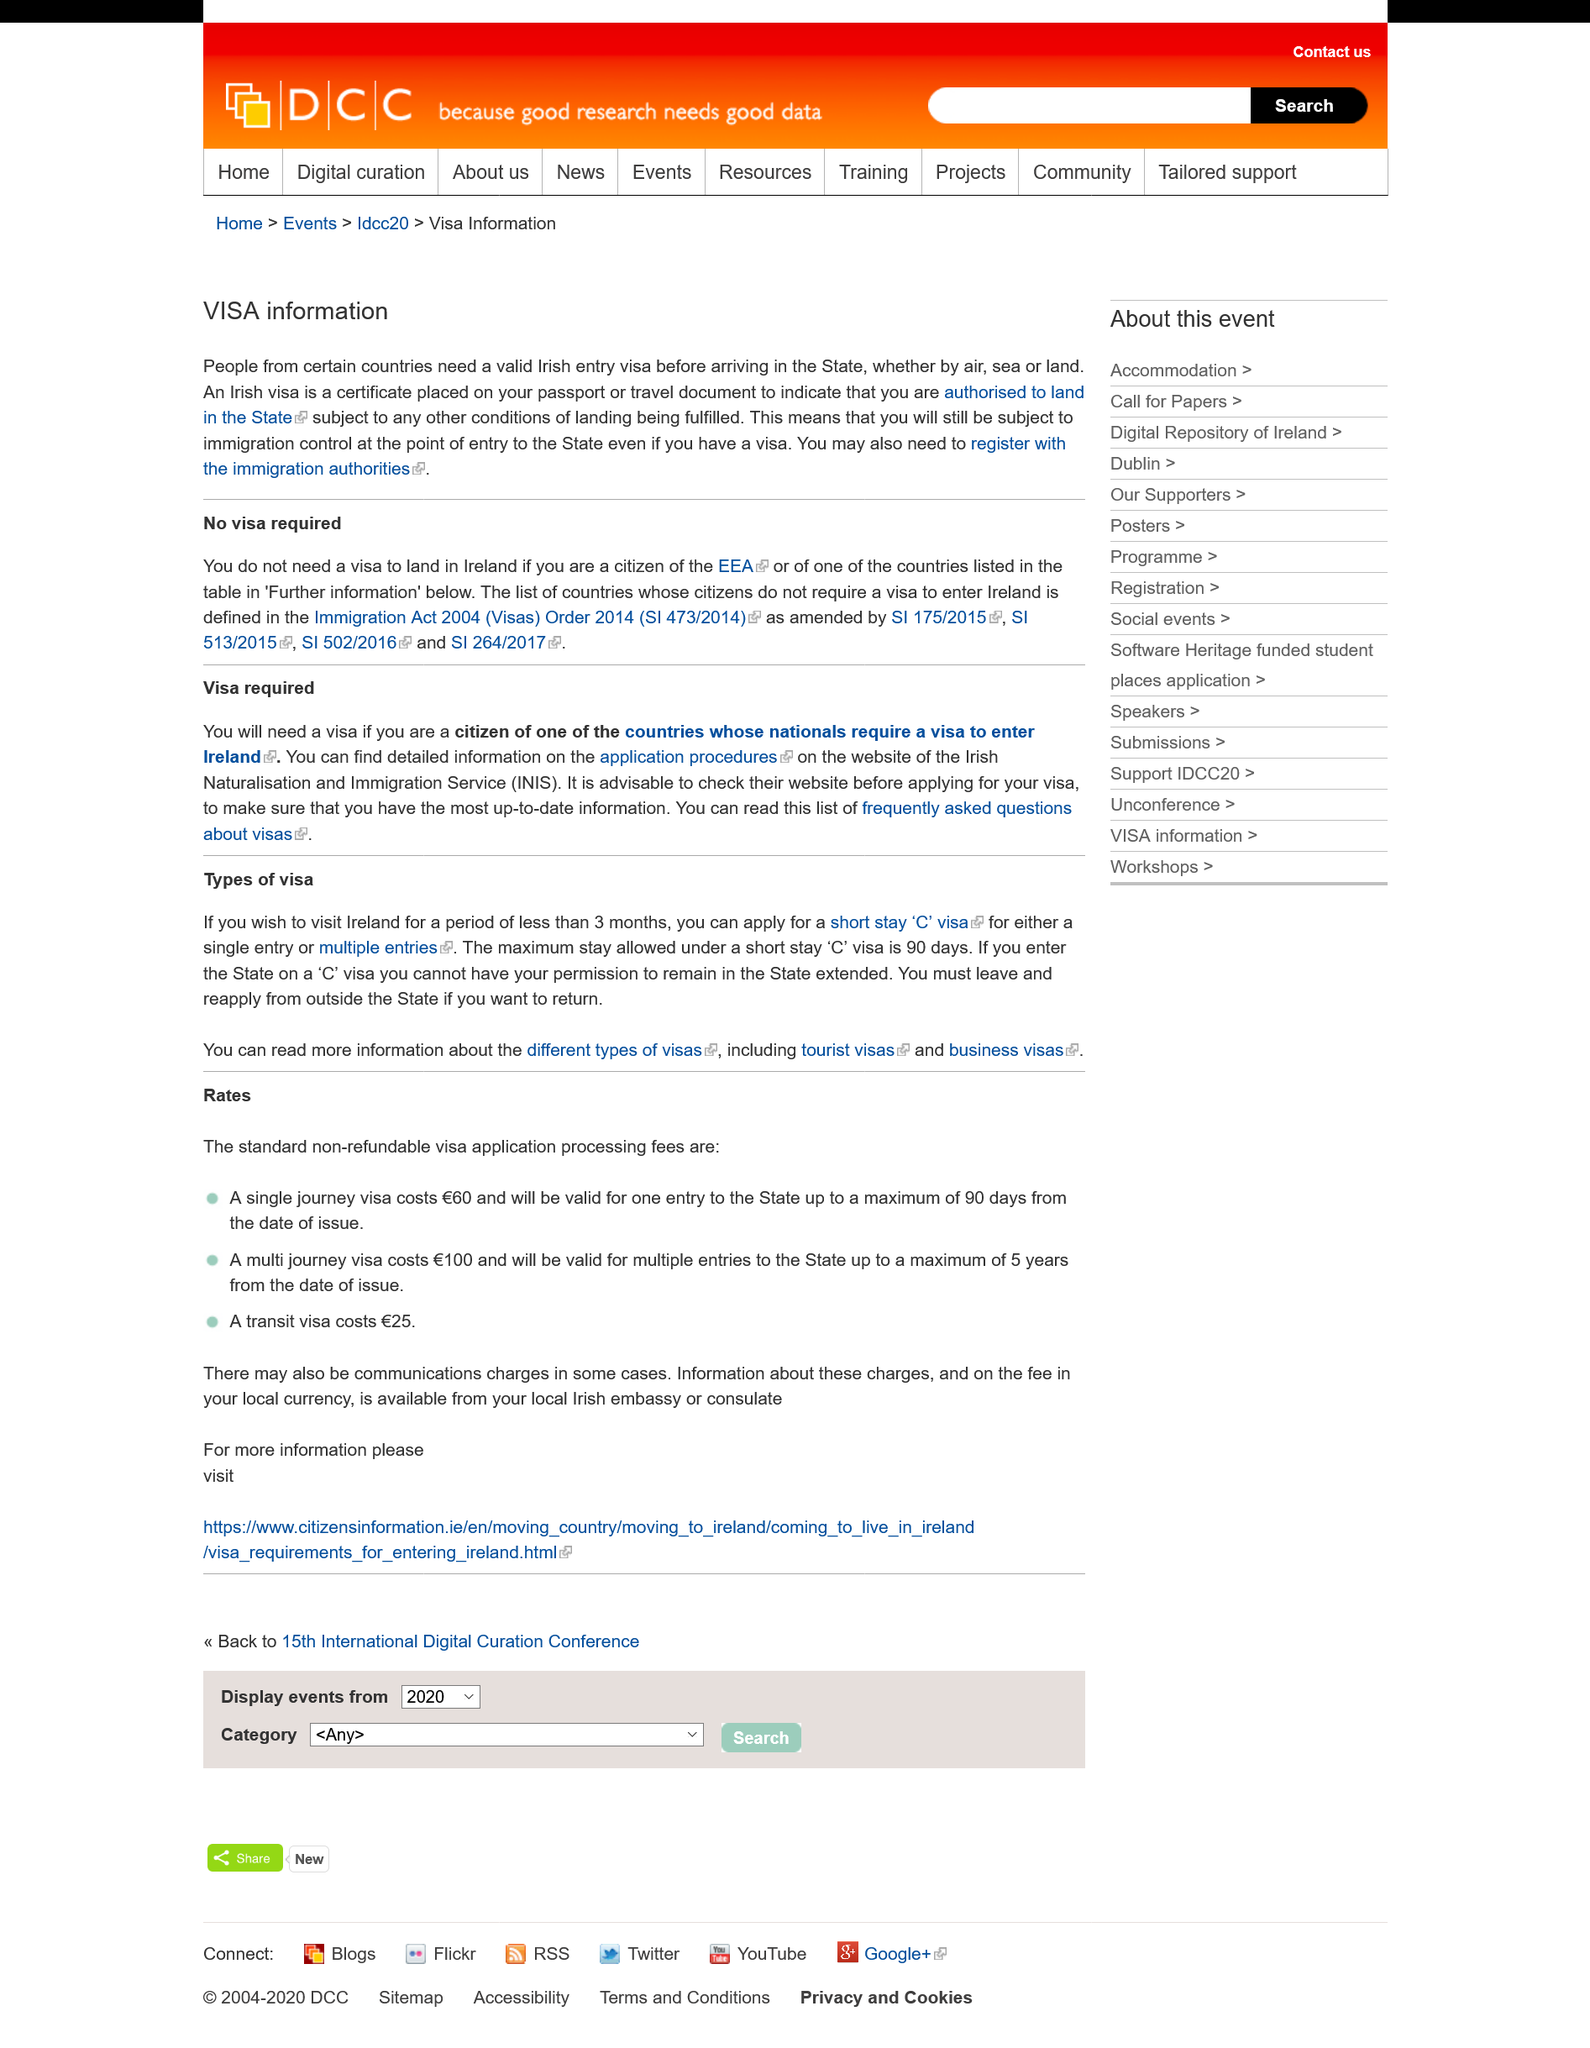Highlight a few significant elements in this photo. If you are a citizen of the EEA or one of the countries listed in the table in "further information," you do not need a visa to land in Ireland. The VISA in question applies to Land, Sea, and Air modes of transport. An Irish visa is a certificate affixed to a passport or travel document that permits an individual to legally land in the State. 